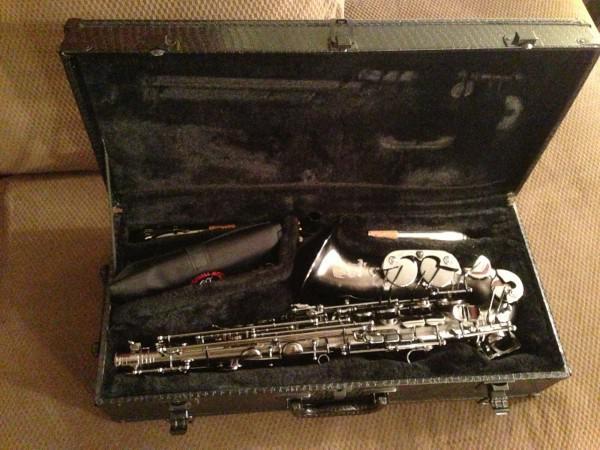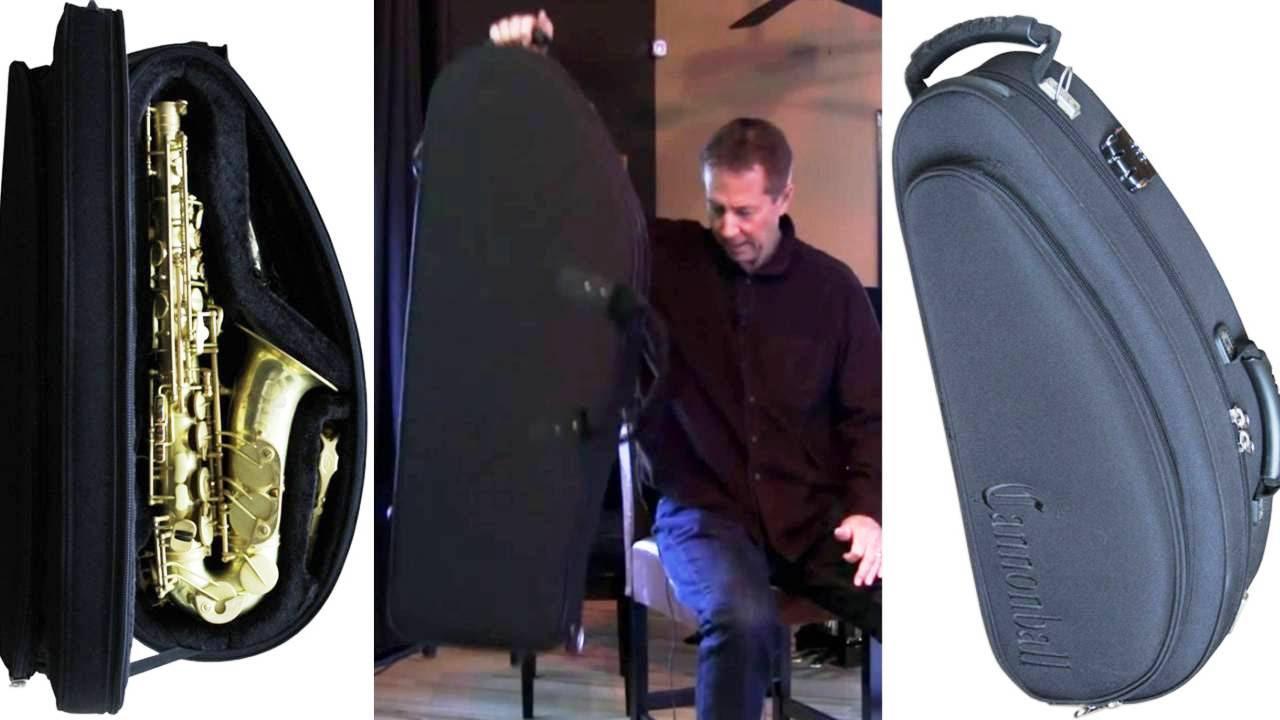The first image is the image on the left, the second image is the image on the right. Evaluate the accuracy of this statement regarding the images: "At least one saxophone case has a burgundy velvet interior.". Is it true? Answer yes or no. No. The first image is the image on the left, the second image is the image on the right. Analyze the images presented: Is the assertion "An image shows a rounded, not rectangular, case, which is lined in black fabric and holds one saxophone." valid? Answer yes or no. Yes. 